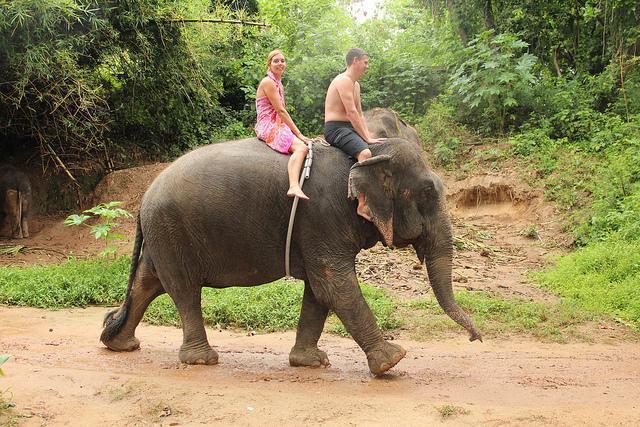What is the slowest thing that can move faster than the large thing here?
Choose the correct response, then elucidate: 'Answer: answer
Rationale: rationale.'
Options: Airplane, car, ant, horse. Answer: horse.
Rationale: Horse moves faster than a car or airplane and ant cannot cover a lot of distance. 